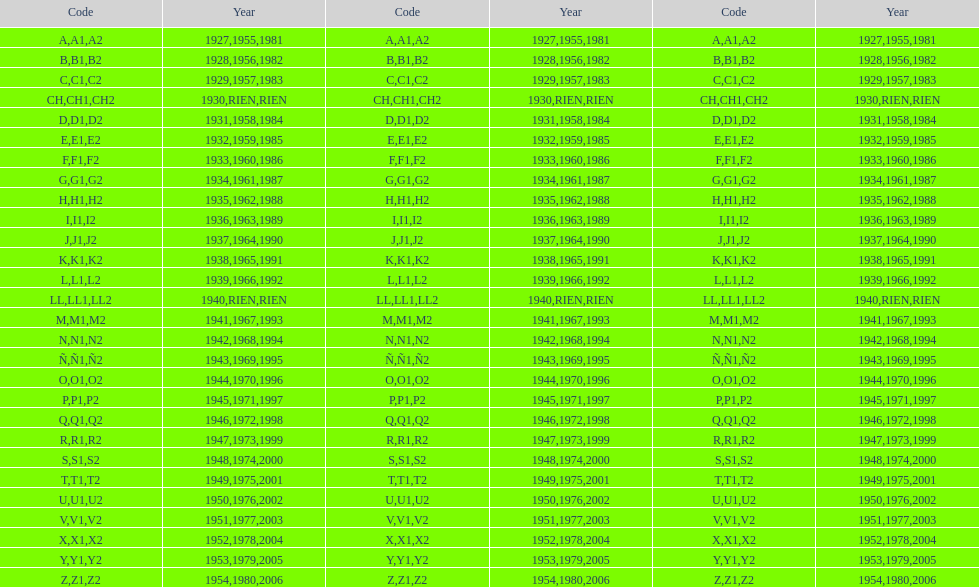List every code not linked with a year. CH1, CH2, LL1, LL2. 